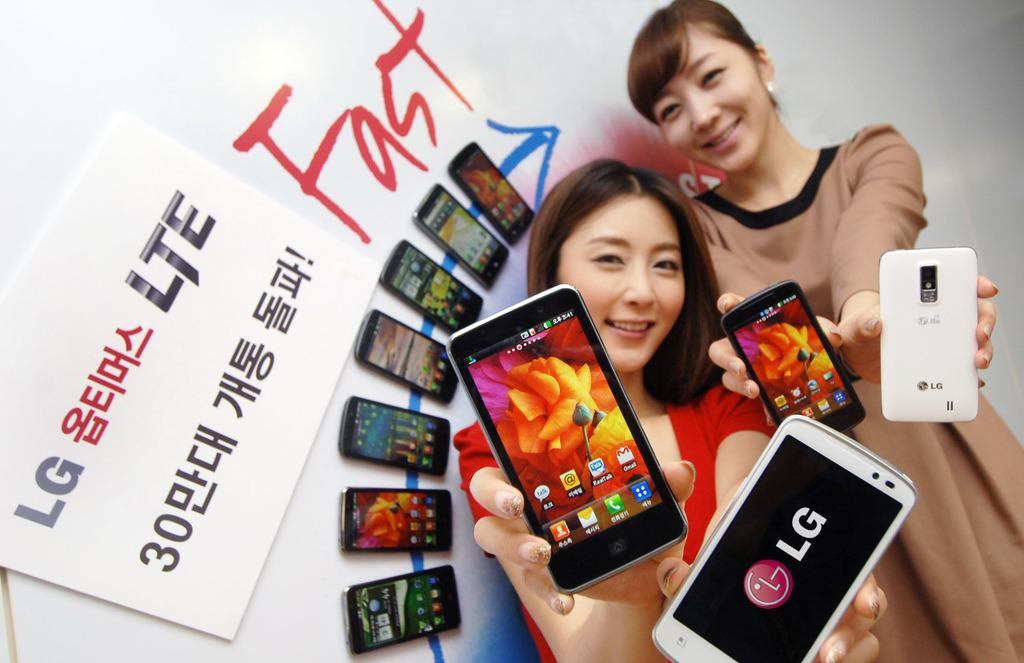<image>
Present a compact description of the photo's key features. LG phone being help by two females next to a sign 